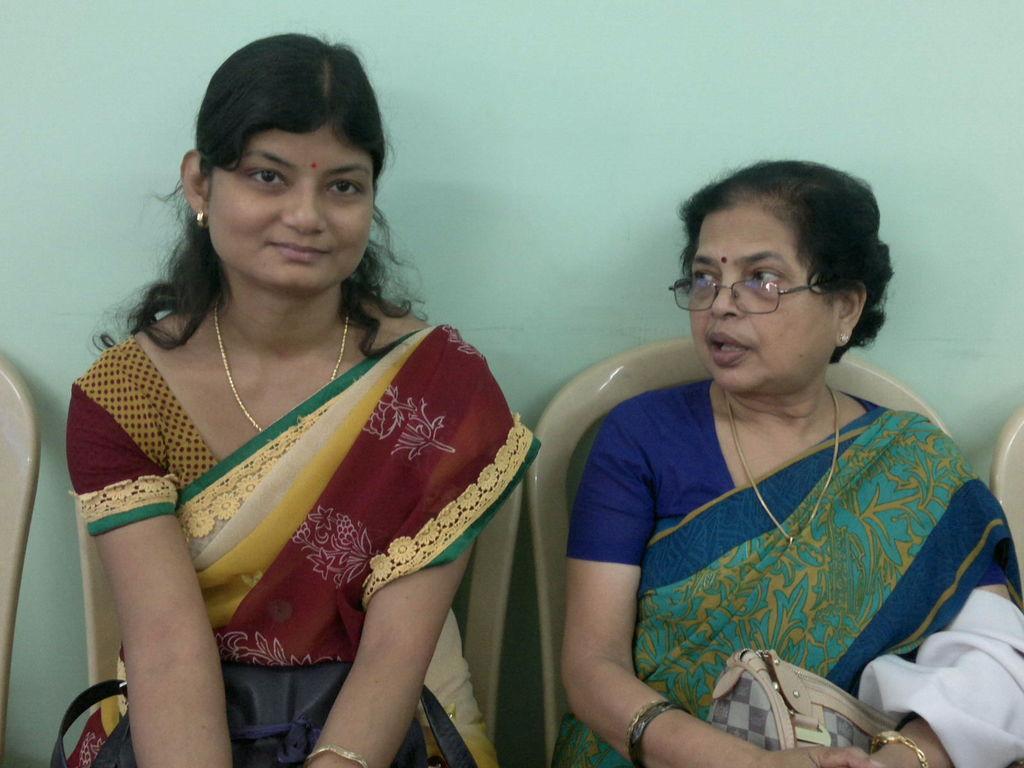In one or two sentences, can you explain what this image depicts? In this image I see 2 women and both of them are sitting on the chair and holding their handbags and I can also see there is a chair on the either side. In the background I can see the wall. 